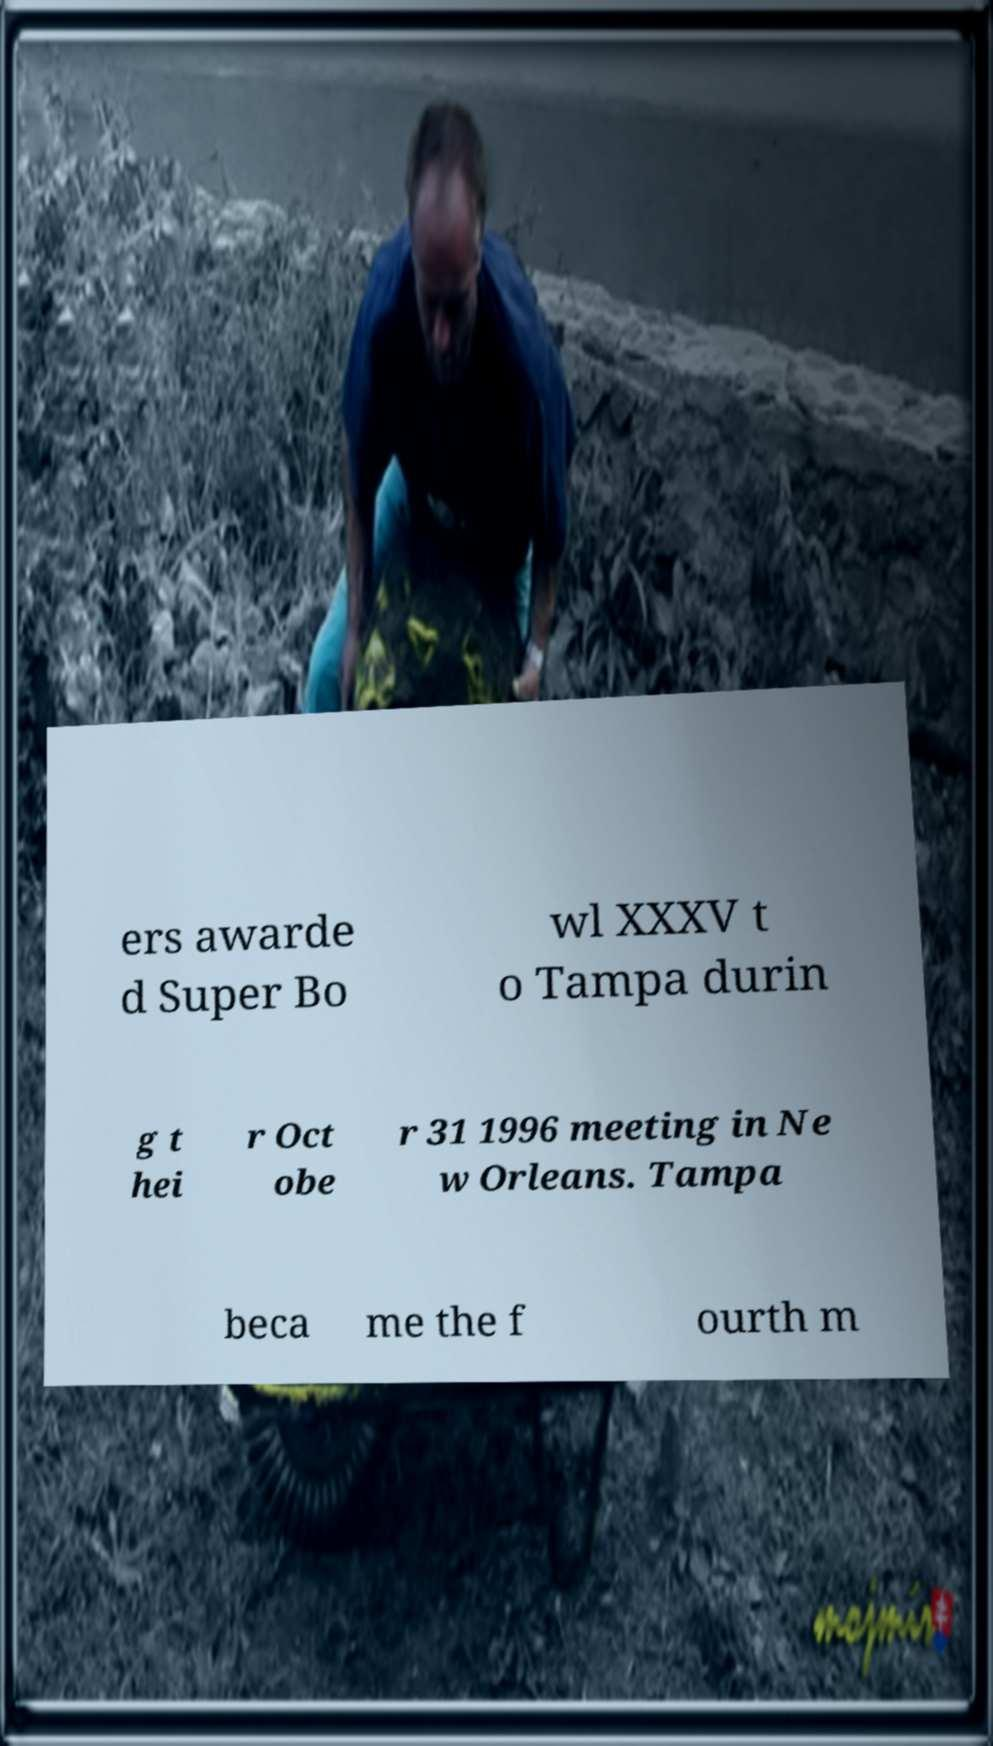Could you assist in decoding the text presented in this image and type it out clearly? ers awarde d Super Bo wl XXXV t o Tampa durin g t hei r Oct obe r 31 1996 meeting in Ne w Orleans. Tampa beca me the f ourth m 